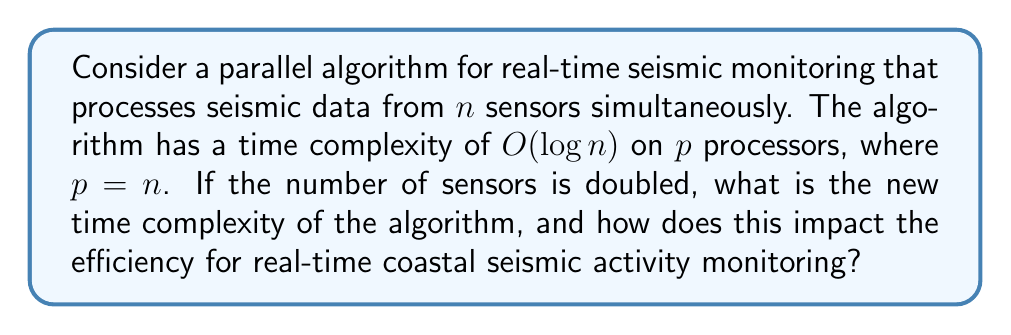Help me with this question. To solve this problem, we need to understand how the time complexity changes when we increase the number of sensors and processors:

1. Initial condition:
   - Number of sensors: $n$
   - Number of processors: $p = n$
   - Time complexity: $O(\log n)$

2. New condition:
   - Number of sensors: $2n$
   - Number of processors: $p = 2n$ (assuming we scale the processors with the sensors)

3. Calculate the new time complexity:
   - The time complexity is based on the number of sensors, so we replace $n$ with $2n$:
     $O(\log (2n))$

4. Simplify using logarithm properties:
   $O(\log (2n)) = O(\log 2 + \log n) = O(1 + \log n) = O(\log n)$

5. Analyze the impact on efficiency:
   - The time complexity remains $O(\log n)$ even when doubling the number of sensors and processors.
   - This indicates that the algorithm scales logarithmically, which is highly efficient for real-time monitoring.
   - The actual processing time will increase slightly due to the constant factor hidden in the big O notation, but the overall complexity class remains the same.

6. Real-world implications:
   - For coastal seismic activity monitoring, this means that the system can handle a significant increase in sensors without a proportional increase in processing time.
   - This allows for more comprehensive coverage of coastal areas without sacrificing real-time performance, which is crucial for early warning systems and rapid response to seismic events.
Answer: The new time complexity is $O(\log n)$, which is the same as the original complexity. This demonstrates excellent scalability, allowing for increased sensor coverage in coastal areas without significantly impacting real-time processing capabilities, thus maintaining efficient seismic activity monitoring. 